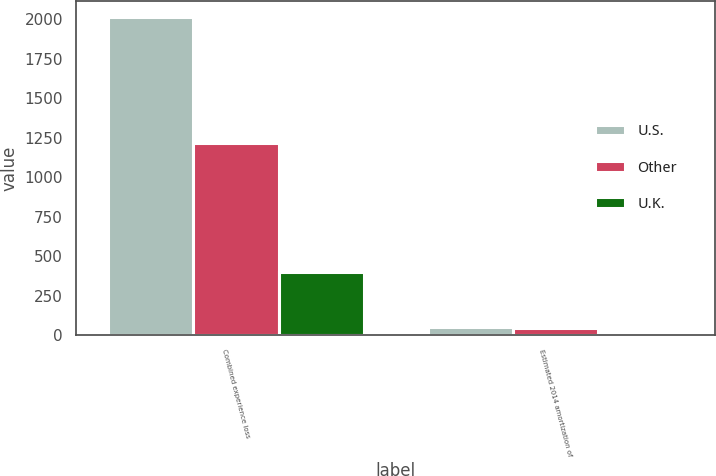Convert chart. <chart><loc_0><loc_0><loc_500><loc_500><stacked_bar_chart><ecel><fcel>Combined experience loss<fcel>Estimated 2014 amortization of<nl><fcel>U.S.<fcel>2012<fcel>53<nl><fcel>Other<fcel>1219<fcel>44<nl><fcel>U.K.<fcel>402<fcel>10<nl></chart> 